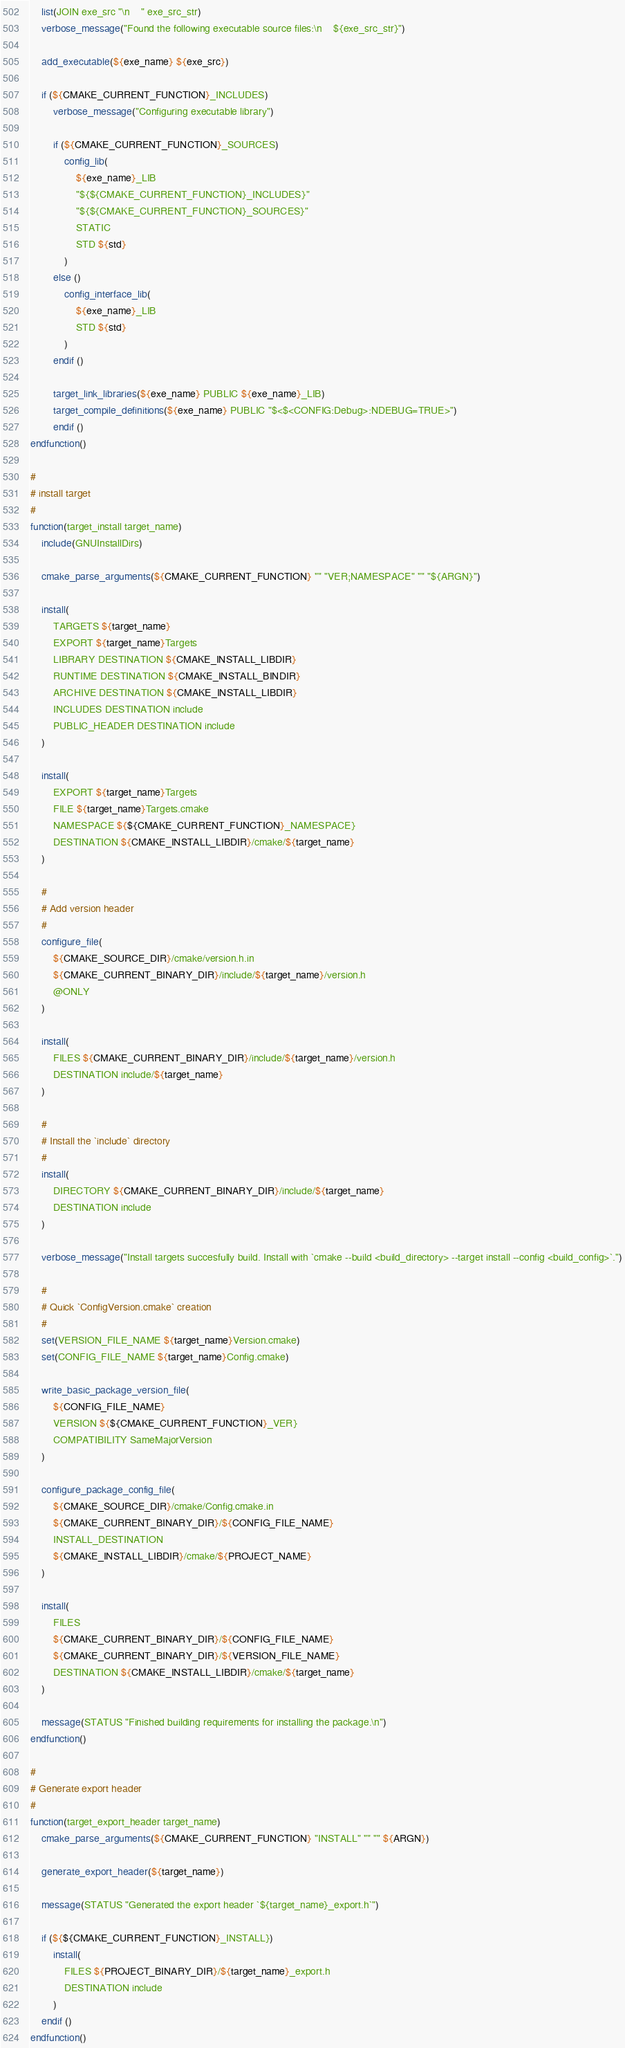Convert code to text. <code><loc_0><loc_0><loc_500><loc_500><_CMake_>    list(JOIN exe_src "\n    " exe_src_str)
    verbose_message("Found the following executable source files:\n    ${exe_src_str}")

    add_executable(${exe_name} ${exe_src})

    if (${CMAKE_CURRENT_FUNCTION}_INCLUDES)
        verbose_message("Configuring executable library")

        if (${CMAKE_CURRENT_FUNCTION}_SOURCES)
            config_lib(
                ${exe_name}_LIB
                "${${CMAKE_CURRENT_FUNCTION}_INCLUDES}"
                "${${CMAKE_CURRENT_FUNCTION}_SOURCES}"
                STATIC
                STD ${std}
            )
        else ()
            config_interface_lib(
                ${exe_name}_LIB
                STD ${std}
            )
        endif ()

        target_link_libraries(${exe_name} PUBLIC ${exe_name}_LIB)
        target_compile_definitions(${exe_name} PUBLIC "$<$<CONFIG:Debug>:NDEBUG=TRUE>")
        endif ()
endfunction()

#
# install target
#
function(target_install target_name)
    include(GNUInstallDirs)

    cmake_parse_arguments(${CMAKE_CURRENT_FUNCTION} "" "VER;NAMESPACE" "" "${ARGN}")

    install(
        TARGETS ${target_name}
        EXPORT ${target_name}Targets
        LIBRARY DESTINATION ${CMAKE_INSTALL_LIBDIR}
        RUNTIME DESTINATION ${CMAKE_INSTALL_BINDIR}
        ARCHIVE DESTINATION ${CMAKE_INSTALL_LIBDIR}
        INCLUDES DESTINATION include
        PUBLIC_HEADER DESTINATION include
    )

    install(
        EXPORT ${target_name}Targets
        FILE ${target_name}Targets.cmake
        NAMESPACE ${${CMAKE_CURRENT_FUNCTION}_NAMESPACE}
        DESTINATION ${CMAKE_INSTALL_LIBDIR}/cmake/${target_name}
    )

    #
    # Add version header
    #
    configure_file(
        ${CMAKE_SOURCE_DIR}/cmake/version.h.in
        ${CMAKE_CURRENT_BINARY_DIR}/include/${target_name}/version.h
        @ONLY
    )

    install(
        FILES ${CMAKE_CURRENT_BINARY_DIR}/include/${target_name}/version.h
        DESTINATION include/${target_name}
    )

    #
    # Install the `include` directory
    #
    install(
        DIRECTORY ${CMAKE_CURRENT_BINARY_DIR}/include/${target_name}
        DESTINATION include
    )

    verbose_message("Install targets succesfully build. Install with `cmake --build <build_directory> --target install --config <build_config>`.")

    #
    # Quick `ConfigVersion.cmake` creation
    #
    set(VERSION_FILE_NAME ${target_name}Version.cmake)
    set(CONFIG_FILE_NAME ${target_name}Config.cmake)

    write_basic_package_version_file(
        ${CONFIG_FILE_NAME}
        VERSION ${${CMAKE_CURRENT_FUNCTION}_VER}
        COMPATIBILITY SameMajorVersion
    )

    configure_package_config_file(
        ${CMAKE_SOURCE_DIR}/cmake/Config.cmake.in
        ${CMAKE_CURRENT_BINARY_DIR}/${CONFIG_FILE_NAME}
        INSTALL_DESTINATION
        ${CMAKE_INSTALL_LIBDIR}/cmake/${PROJECT_NAME}
    )

    install(
        FILES
        ${CMAKE_CURRENT_BINARY_DIR}/${CONFIG_FILE_NAME}
        ${CMAKE_CURRENT_BINARY_DIR}/${VERSION_FILE_NAME}
        DESTINATION ${CMAKE_INSTALL_LIBDIR}/cmake/${target_name}
    )

    message(STATUS "Finished building requirements for installing the package.\n")
endfunction()

#
# Generate export header
#
function(target_export_header target_name)
    cmake_parse_arguments(${CMAKE_CURRENT_FUNCTION} "INSTALL" "" "" ${ARGN})

    generate_export_header(${target_name})

    message(STATUS "Generated the export header `${target_name}_export.h`")

    if (${${CMAKE_CURRENT_FUNCTION}_INSTALL})
        install(
            FILES ${PROJECT_BINARY_DIR}/${target_name}_export.h
            DESTINATION include
        )
    endif ()
endfunction()
</code> 